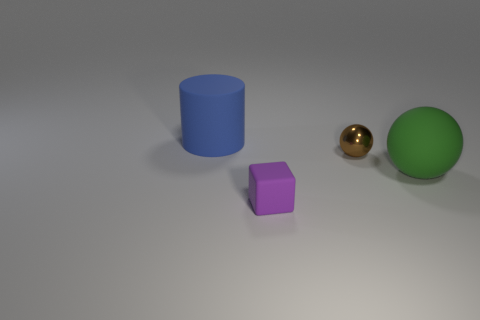There is a thing that is in front of the big green rubber sphere; what is it made of? The object in front of the big green rubber sphere is a shiny, golden sphere. Considering its reflective surface and metallic sheen, it likely represents a material like metal, possibly intended to mimic the appearance of gold or brass. 